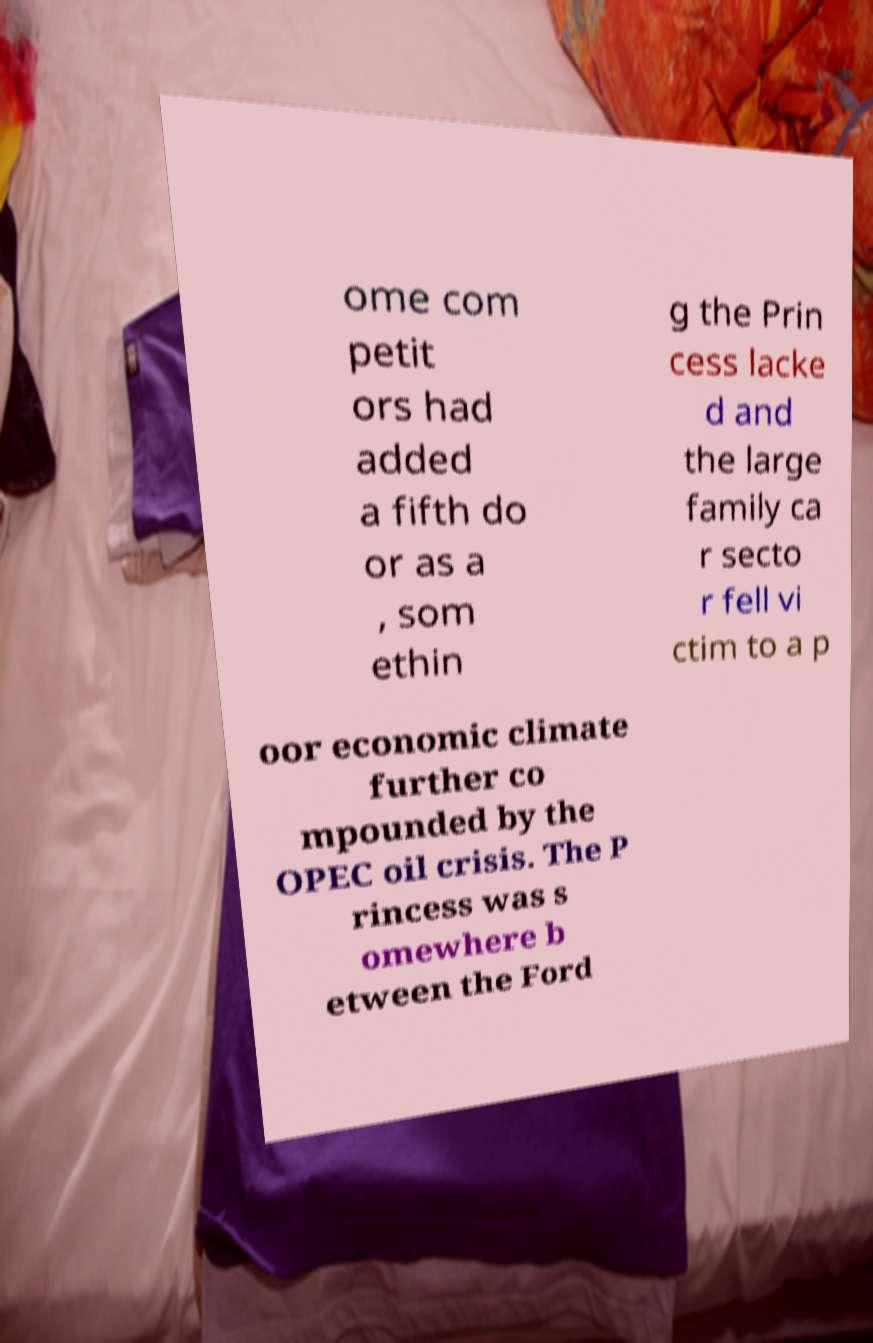Could you assist in decoding the text presented in this image and type it out clearly? ome com petit ors had added a fifth do or as a , som ethin g the Prin cess lacke d and the large family ca r secto r fell vi ctim to a p oor economic climate further co mpounded by the OPEC oil crisis. The P rincess was s omewhere b etween the Ford 